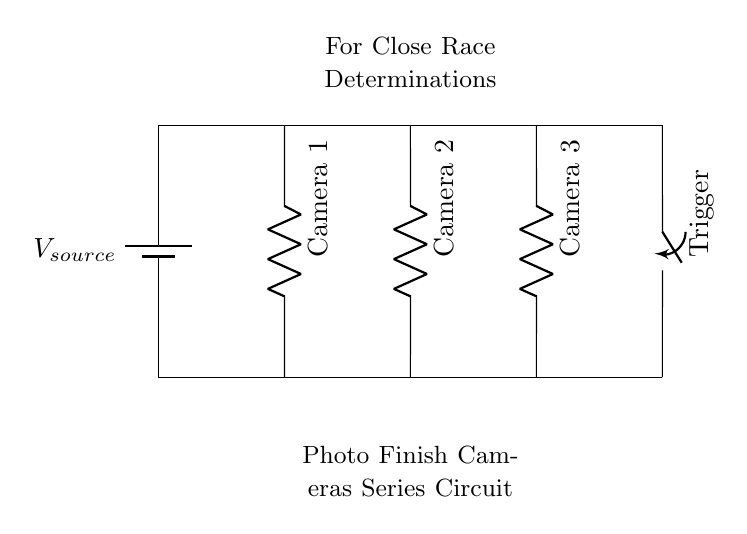What type of circuit is depicted? The circuit is a series circuit, as indicated by the arrangement of the components where current flows through each component in a single path.
Answer: Series circuit How many cameras are in the circuit? The circuit contains three cameras, which can be counted by identifying the camera symbols drawn in the diagram.
Answer: Three What component is used to trigger the cameras? The triggering of the cameras is controlled by a switch, as represented by the switch symbol connecting the circuit.
Answer: Switch What happens to the current if one camera fails? In a series circuit, if one component (like a camera) fails, the current will stop flowing throughout the entire circuit, meaning all cameras will cease to function.
Answer: Stop What is the total resistance if each camera has a resistance of 10 ohms? The total resistance in a series circuit is the sum of all individual resistances, so total resistance is calculated as 10 ohms for each camera multiplied by 3 cameras, which equals 30 ohms.
Answer: 30 ohms What is the purpose of this circuit? The purpose of this circuit is to accurately capture the finish of a race using multiple photo finish cameras, as stated in the label of the circuit diagram.
Answer: Close race determinations 